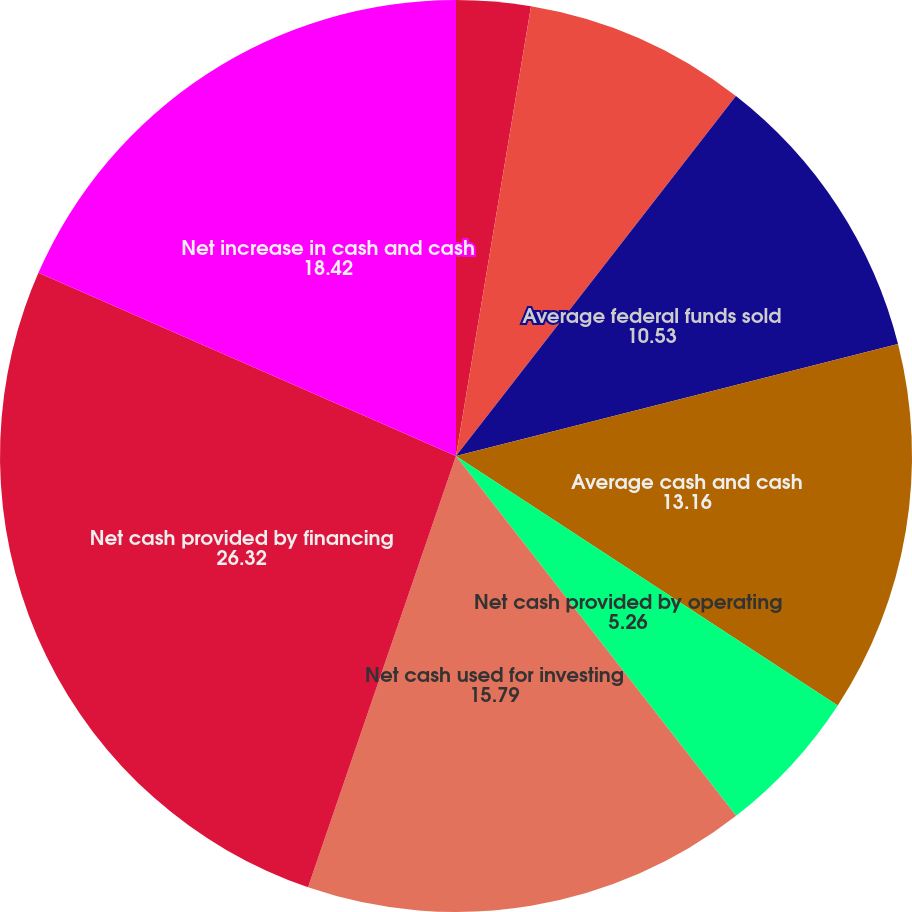Convert chart. <chart><loc_0><loc_0><loc_500><loc_500><pie_chart><fcel>(Dollars in thousands)<fcel>Average cash and due from<fcel>Average federal funds sold<fcel>Average cash and cash<fcel>Percentage of total average<fcel>Net cash provided by operating<fcel>Net cash used for investing<fcel>Net cash provided by financing<fcel>Net increase in cash and cash<nl><fcel>2.63%<fcel>7.89%<fcel>10.53%<fcel>13.16%<fcel>0.0%<fcel>5.26%<fcel>15.79%<fcel>26.32%<fcel>18.42%<nl></chart> 